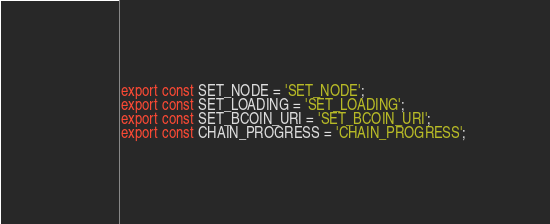<code> <loc_0><loc_0><loc_500><loc_500><_JavaScript_>export const SET_NODE = 'SET_NODE';
export const SET_LOADING = 'SET_LOADING';
export const SET_BCOIN_URI = 'SET_BCOIN_URI';
export const CHAIN_PROGRESS = 'CHAIN_PROGRESS';
</code> 